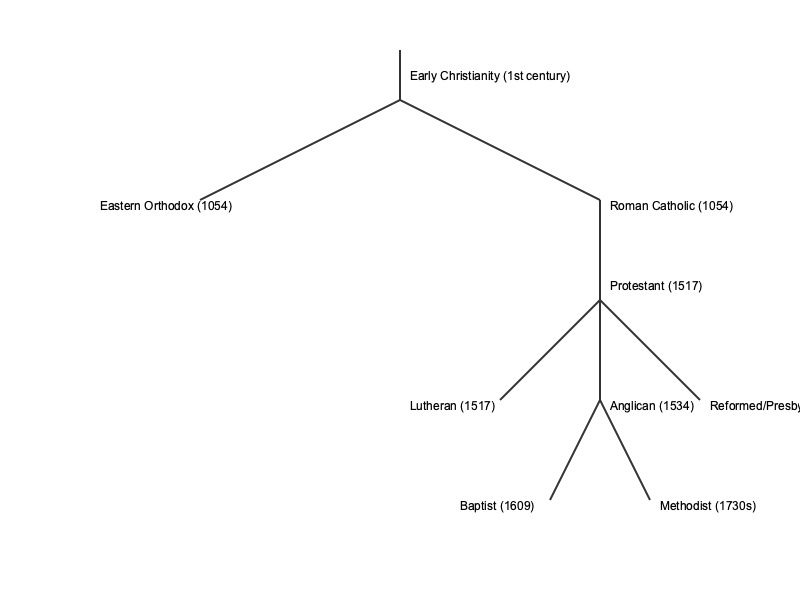Based on the branching tree diagram of Christian denominations, which major branch of Christianity emerged first, and what significant event in 1517 led to a further division within Western Christianity? To answer this question, we need to analyze the branching tree diagram of Christian denominations:

1. The diagram shows Early Christianity at the top, representing the origins of the Christian faith in the 1st century.

2. The first major split occurs in 1054, resulting in two branches:
   a) Eastern Orthodox
   b) Roman Catholic

3. This split is known as the Great Schism, which divided Christianity into Eastern (Orthodox) and Western (Catholic) branches.

4. The next significant event occurs in 1517, branching off from the Roman Catholic line. This represents the Protestant Reformation.

5. The Protestant Reformation, initiated by Martin Luther in 1517, led to the emergence of various Protestant denominations, including:
   a) Lutheran (1517)
   b) Anglican (1534)
   c) Reformed/Presbyterian (1550s)
   d) Baptist (1609)
   e) Methodist (1730s)

6. The first major branch to emerge from Early Christianity was the split between Eastern Orthodox and Roman Catholic in 1054.

7. The significant event in 1517 that led to further division within Western Christianity was the Protestant Reformation, which gave rise to numerous Protestant denominations.
Answer: Eastern Orthodox (1054); Protestant Reformation (1517) 